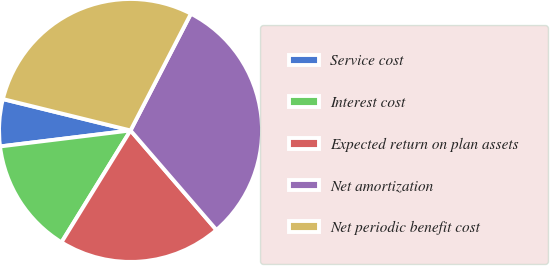<chart> <loc_0><loc_0><loc_500><loc_500><pie_chart><fcel>Service cost<fcel>Interest cost<fcel>Expected return on plan assets<fcel>Net amortization<fcel>Net periodic benefit cost<nl><fcel>5.78%<fcel>14.26%<fcel>20.14%<fcel>31.07%<fcel>28.76%<nl></chart> 